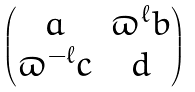<formula> <loc_0><loc_0><loc_500><loc_500>\begin{pmatrix} a & \varpi ^ { \ell } b \\ \varpi ^ { - \ell } c & d \end{pmatrix}</formula> 